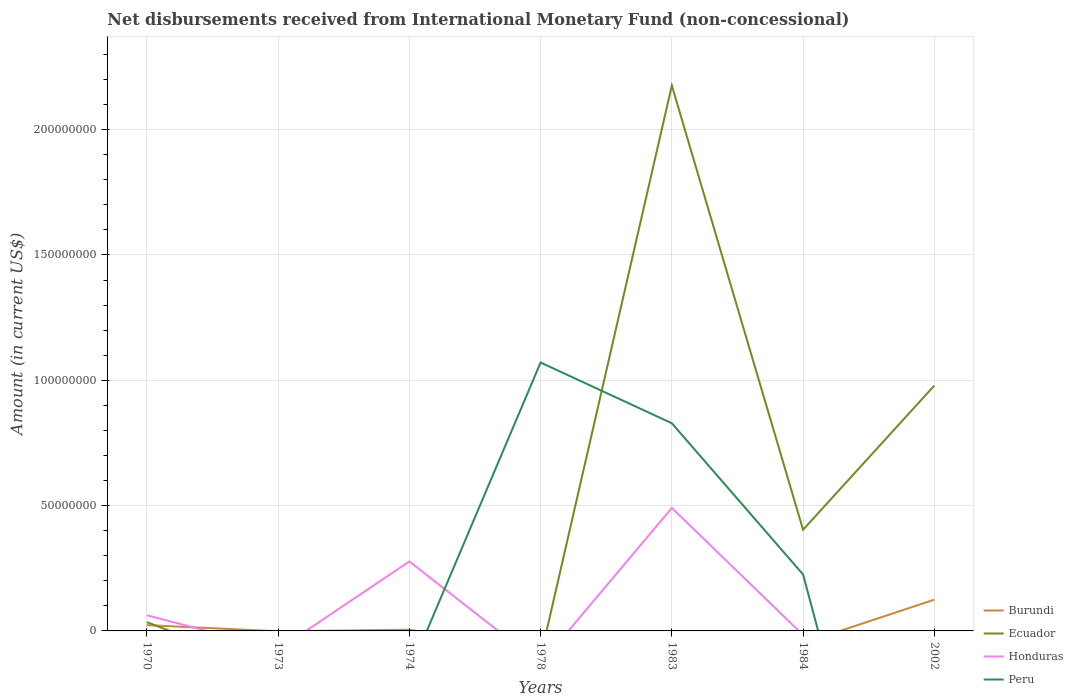How many different coloured lines are there?
Your response must be concise. 4. Is the number of lines equal to the number of legend labels?
Offer a very short reply. No. Across all years, what is the maximum amount of disbursements received from International Monetary Fund in Burundi?
Your response must be concise. 0. What is the total amount of disbursements received from International Monetary Fund in Burundi in the graph?
Your response must be concise. -1.20e+07. What is the difference between the highest and the second highest amount of disbursements received from International Monetary Fund in Burundi?
Offer a terse response. 1.25e+07. What is the difference between the highest and the lowest amount of disbursements received from International Monetary Fund in Burundi?
Provide a succinct answer. 2. What is the difference between two consecutive major ticks on the Y-axis?
Make the answer very short. 5.00e+07. Are the values on the major ticks of Y-axis written in scientific E-notation?
Give a very brief answer. No. Does the graph contain any zero values?
Give a very brief answer. Yes. How are the legend labels stacked?
Make the answer very short. Vertical. What is the title of the graph?
Offer a very short reply. Net disbursements received from International Monetary Fund (non-concessional). What is the label or title of the X-axis?
Keep it short and to the point. Years. What is the label or title of the Y-axis?
Your answer should be compact. Amount (in current US$). What is the Amount (in current US$) of Burundi in 1970?
Your answer should be very brief. 2.31e+06. What is the Amount (in current US$) in Ecuador in 1970?
Offer a very short reply. 3.50e+06. What is the Amount (in current US$) in Honduras in 1970?
Keep it short and to the point. 6.25e+06. What is the Amount (in current US$) of Burundi in 1973?
Ensure brevity in your answer.  0. What is the Amount (in current US$) in Ecuador in 1973?
Offer a terse response. 0. What is the Amount (in current US$) in Peru in 1973?
Your response must be concise. 0. What is the Amount (in current US$) in Burundi in 1974?
Your answer should be compact. 4.69e+05. What is the Amount (in current US$) in Ecuador in 1974?
Give a very brief answer. 0. What is the Amount (in current US$) in Honduras in 1974?
Offer a terse response. 2.77e+07. What is the Amount (in current US$) in Peru in 1974?
Give a very brief answer. 0. What is the Amount (in current US$) in Burundi in 1978?
Your answer should be very brief. 0. What is the Amount (in current US$) of Peru in 1978?
Give a very brief answer. 1.07e+08. What is the Amount (in current US$) of Ecuador in 1983?
Ensure brevity in your answer.  2.18e+08. What is the Amount (in current US$) in Honduras in 1983?
Provide a succinct answer. 4.91e+07. What is the Amount (in current US$) in Peru in 1983?
Provide a short and direct response. 8.28e+07. What is the Amount (in current US$) in Burundi in 1984?
Offer a very short reply. 0. What is the Amount (in current US$) of Ecuador in 1984?
Your answer should be compact. 4.04e+07. What is the Amount (in current US$) in Honduras in 1984?
Offer a very short reply. 0. What is the Amount (in current US$) of Peru in 1984?
Your response must be concise. 2.25e+07. What is the Amount (in current US$) of Burundi in 2002?
Give a very brief answer. 1.25e+07. What is the Amount (in current US$) of Ecuador in 2002?
Give a very brief answer. 9.79e+07. What is the Amount (in current US$) of Peru in 2002?
Make the answer very short. 0. Across all years, what is the maximum Amount (in current US$) in Burundi?
Keep it short and to the point. 1.25e+07. Across all years, what is the maximum Amount (in current US$) in Ecuador?
Offer a very short reply. 2.18e+08. Across all years, what is the maximum Amount (in current US$) of Honduras?
Offer a terse response. 4.91e+07. Across all years, what is the maximum Amount (in current US$) in Peru?
Give a very brief answer. 1.07e+08. Across all years, what is the minimum Amount (in current US$) in Burundi?
Offer a very short reply. 0. Across all years, what is the minimum Amount (in current US$) of Ecuador?
Offer a very short reply. 0. Across all years, what is the minimum Amount (in current US$) in Honduras?
Your answer should be very brief. 0. What is the total Amount (in current US$) of Burundi in the graph?
Your response must be concise. 1.52e+07. What is the total Amount (in current US$) of Ecuador in the graph?
Offer a very short reply. 3.59e+08. What is the total Amount (in current US$) in Honduras in the graph?
Give a very brief answer. 8.30e+07. What is the total Amount (in current US$) in Peru in the graph?
Provide a succinct answer. 2.12e+08. What is the difference between the Amount (in current US$) of Burundi in 1970 and that in 1974?
Provide a short and direct response. 1.84e+06. What is the difference between the Amount (in current US$) in Honduras in 1970 and that in 1974?
Give a very brief answer. -2.15e+07. What is the difference between the Amount (in current US$) in Ecuador in 1970 and that in 1983?
Your response must be concise. -2.14e+08. What is the difference between the Amount (in current US$) in Honduras in 1970 and that in 1983?
Provide a short and direct response. -4.28e+07. What is the difference between the Amount (in current US$) of Ecuador in 1970 and that in 1984?
Your answer should be very brief. -3.69e+07. What is the difference between the Amount (in current US$) in Burundi in 1970 and that in 2002?
Offer a very short reply. -1.02e+07. What is the difference between the Amount (in current US$) in Ecuador in 1970 and that in 2002?
Your answer should be compact. -9.44e+07. What is the difference between the Amount (in current US$) in Honduras in 1974 and that in 1983?
Offer a terse response. -2.14e+07. What is the difference between the Amount (in current US$) in Burundi in 1974 and that in 2002?
Ensure brevity in your answer.  -1.20e+07. What is the difference between the Amount (in current US$) in Peru in 1978 and that in 1983?
Provide a short and direct response. 2.42e+07. What is the difference between the Amount (in current US$) of Peru in 1978 and that in 1984?
Offer a very short reply. 8.46e+07. What is the difference between the Amount (in current US$) of Ecuador in 1983 and that in 1984?
Keep it short and to the point. 1.77e+08. What is the difference between the Amount (in current US$) in Peru in 1983 and that in 1984?
Keep it short and to the point. 6.03e+07. What is the difference between the Amount (in current US$) of Ecuador in 1983 and that in 2002?
Provide a short and direct response. 1.20e+08. What is the difference between the Amount (in current US$) of Ecuador in 1984 and that in 2002?
Your answer should be compact. -5.75e+07. What is the difference between the Amount (in current US$) in Burundi in 1970 and the Amount (in current US$) in Honduras in 1974?
Keep it short and to the point. -2.54e+07. What is the difference between the Amount (in current US$) in Ecuador in 1970 and the Amount (in current US$) in Honduras in 1974?
Give a very brief answer. -2.42e+07. What is the difference between the Amount (in current US$) of Burundi in 1970 and the Amount (in current US$) of Peru in 1978?
Provide a succinct answer. -1.05e+08. What is the difference between the Amount (in current US$) of Ecuador in 1970 and the Amount (in current US$) of Peru in 1978?
Provide a short and direct response. -1.04e+08. What is the difference between the Amount (in current US$) of Honduras in 1970 and the Amount (in current US$) of Peru in 1978?
Offer a terse response. -1.01e+08. What is the difference between the Amount (in current US$) in Burundi in 1970 and the Amount (in current US$) in Ecuador in 1983?
Your answer should be very brief. -2.15e+08. What is the difference between the Amount (in current US$) of Burundi in 1970 and the Amount (in current US$) of Honduras in 1983?
Give a very brief answer. -4.68e+07. What is the difference between the Amount (in current US$) in Burundi in 1970 and the Amount (in current US$) in Peru in 1983?
Ensure brevity in your answer.  -8.05e+07. What is the difference between the Amount (in current US$) of Ecuador in 1970 and the Amount (in current US$) of Honduras in 1983?
Provide a short and direct response. -4.56e+07. What is the difference between the Amount (in current US$) of Ecuador in 1970 and the Amount (in current US$) of Peru in 1983?
Your answer should be very brief. -7.94e+07. What is the difference between the Amount (in current US$) in Honduras in 1970 and the Amount (in current US$) in Peru in 1983?
Provide a short and direct response. -7.66e+07. What is the difference between the Amount (in current US$) of Burundi in 1970 and the Amount (in current US$) of Ecuador in 1984?
Keep it short and to the point. -3.80e+07. What is the difference between the Amount (in current US$) in Burundi in 1970 and the Amount (in current US$) in Peru in 1984?
Offer a terse response. -2.02e+07. What is the difference between the Amount (in current US$) of Ecuador in 1970 and the Amount (in current US$) of Peru in 1984?
Offer a terse response. -1.90e+07. What is the difference between the Amount (in current US$) of Honduras in 1970 and the Amount (in current US$) of Peru in 1984?
Provide a succinct answer. -1.63e+07. What is the difference between the Amount (in current US$) of Burundi in 1970 and the Amount (in current US$) of Ecuador in 2002?
Offer a very short reply. -9.56e+07. What is the difference between the Amount (in current US$) in Burundi in 1974 and the Amount (in current US$) in Peru in 1978?
Your response must be concise. -1.07e+08. What is the difference between the Amount (in current US$) in Honduras in 1974 and the Amount (in current US$) in Peru in 1978?
Offer a terse response. -7.94e+07. What is the difference between the Amount (in current US$) of Burundi in 1974 and the Amount (in current US$) of Ecuador in 1983?
Keep it short and to the point. -2.17e+08. What is the difference between the Amount (in current US$) in Burundi in 1974 and the Amount (in current US$) in Honduras in 1983?
Keep it short and to the point. -4.86e+07. What is the difference between the Amount (in current US$) in Burundi in 1974 and the Amount (in current US$) in Peru in 1983?
Offer a terse response. -8.24e+07. What is the difference between the Amount (in current US$) of Honduras in 1974 and the Amount (in current US$) of Peru in 1983?
Offer a very short reply. -5.51e+07. What is the difference between the Amount (in current US$) of Burundi in 1974 and the Amount (in current US$) of Ecuador in 1984?
Offer a terse response. -3.99e+07. What is the difference between the Amount (in current US$) of Burundi in 1974 and the Amount (in current US$) of Peru in 1984?
Give a very brief answer. -2.21e+07. What is the difference between the Amount (in current US$) of Honduras in 1974 and the Amount (in current US$) of Peru in 1984?
Offer a very short reply. 5.19e+06. What is the difference between the Amount (in current US$) in Burundi in 1974 and the Amount (in current US$) in Ecuador in 2002?
Offer a very short reply. -9.74e+07. What is the difference between the Amount (in current US$) in Ecuador in 1983 and the Amount (in current US$) in Peru in 1984?
Provide a succinct answer. 1.95e+08. What is the difference between the Amount (in current US$) in Honduras in 1983 and the Amount (in current US$) in Peru in 1984?
Offer a terse response. 2.66e+07. What is the average Amount (in current US$) of Burundi per year?
Keep it short and to the point. 2.18e+06. What is the average Amount (in current US$) in Ecuador per year?
Provide a short and direct response. 5.13e+07. What is the average Amount (in current US$) of Honduras per year?
Your answer should be compact. 1.19e+07. What is the average Amount (in current US$) of Peru per year?
Offer a very short reply. 3.04e+07. In the year 1970, what is the difference between the Amount (in current US$) in Burundi and Amount (in current US$) in Ecuador?
Provide a succinct answer. -1.19e+06. In the year 1970, what is the difference between the Amount (in current US$) in Burundi and Amount (in current US$) in Honduras?
Offer a very short reply. -3.94e+06. In the year 1970, what is the difference between the Amount (in current US$) of Ecuador and Amount (in current US$) of Honduras?
Offer a terse response. -2.75e+06. In the year 1974, what is the difference between the Amount (in current US$) of Burundi and Amount (in current US$) of Honduras?
Provide a succinct answer. -2.72e+07. In the year 1983, what is the difference between the Amount (in current US$) in Ecuador and Amount (in current US$) in Honduras?
Your answer should be compact. 1.68e+08. In the year 1983, what is the difference between the Amount (in current US$) in Ecuador and Amount (in current US$) in Peru?
Give a very brief answer. 1.35e+08. In the year 1983, what is the difference between the Amount (in current US$) in Honduras and Amount (in current US$) in Peru?
Provide a succinct answer. -3.38e+07. In the year 1984, what is the difference between the Amount (in current US$) of Ecuador and Amount (in current US$) of Peru?
Provide a succinct answer. 1.78e+07. In the year 2002, what is the difference between the Amount (in current US$) in Burundi and Amount (in current US$) in Ecuador?
Give a very brief answer. -8.54e+07. What is the ratio of the Amount (in current US$) in Burundi in 1970 to that in 1974?
Make the answer very short. 4.93. What is the ratio of the Amount (in current US$) in Honduras in 1970 to that in 1974?
Ensure brevity in your answer.  0.23. What is the ratio of the Amount (in current US$) in Ecuador in 1970 to that in 1983?
Keep it short and to the point. 0.02. What is the ratio of the Amount (in current US$) of Honduras in 1970 to that in 1983?
Your response must be concise. 0.13. What is the ratio of the Amount (in current US$) of Ecuador in 1970 to that in 1984?
Make the answer very short. 0.09. What is the ratio of the Amount (in current US$) of Burundi in 1970 to that in 2002?
Your response must be concise. 0.19. What is the ratio of the Amount (in current US$) of Ecuador in 1970 to that in 2002?
Your answer should be very brief. 0.04. What is the ratio of the Amount (in current US$) of Honduras in 1974 to that in 1983?
Your response must be concise. 0.56. What is the ratio of the Amount (in current US$) of Burundi in 1974 to that in 2002?
Give a very brief answer. 0.04. What is the ratio of the Amount (in current US$) of Peru in 1978 to that in 1983?
Offer a very short reply. 1.29. What is the ratio of the Amount (in current US$) in Peru in 1978 to that in 1984?
Make the answer very short. 4.75. What is the ratio of the Amount (in current US$) of Ecuador in 1983 to that in 1984?
Offer a terse response. 5.39. What is the ratio of the Amount (in current US$) of Peru in 1983 to that in 1984?
Provide a short and direct response. 3.68. What is the ratio of the Amount (in current US$) of Ecuador in 1983 to that in 2002?
Your answer should be compact. 2.22. What is the ratio of the Amount (in current US$) in Ecuador in 1984 to that in 2002?
Give a very brief answer. 0.41. What is the difference between the highest and the second highest Amount (in current US$) of Burundi?
Offer a very short reply. 1.02e+07. What is the difference between the highest and the second highest Amount (in current US$) in Ecuador?
Offer a terse response. 1.20e+08. What is the difference between the highest and the second highest Amount (in current US$) in Honduras?
Make the answer very short. 2.14e+07. What is the difference between the highest and the second highest Amount (in current US$) of Peru?
Give a very brief answer. 2.42e+07. What is the difference between the highest and the lowest Amount (in current US$) in Burundi?
Keep it short and to the point. 1.25e+07. What is the difference between the highest and the lowest Amount (in current US$) in Ecuador?
Your answer should be compact. 2.18e+08. What is the difference between the highest and the lowest Amount (in current US$) in Honduras?
Offer a very short reply. 4.91e+07. What is the difference between the highest and the lowest Amount (in current US$) of Peru?
Ensure brevity in your answer.  1.07e+08. 